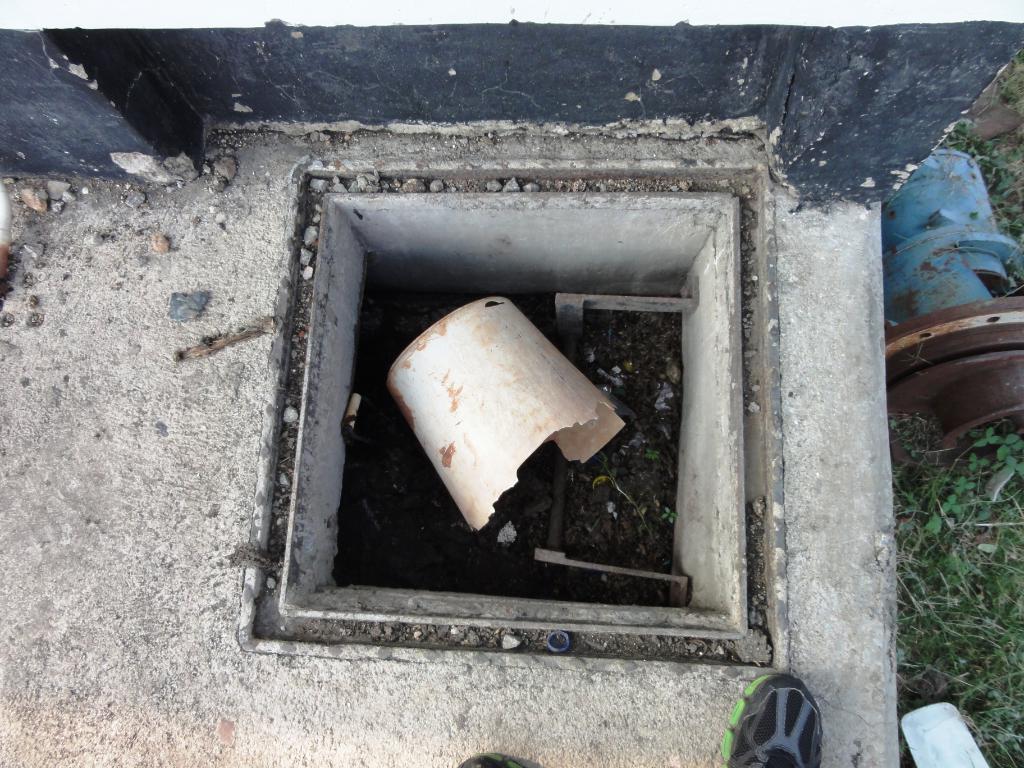Can you describe this image briefly? In the center of the image we can see a hole. In that we can see a bucket and some dust particles. At the top of the image we can see the wall. On the right side of the image we can see a engine, grass. At the bottom of the image we can see a person shoes. In the background of the image we can see the floor. 